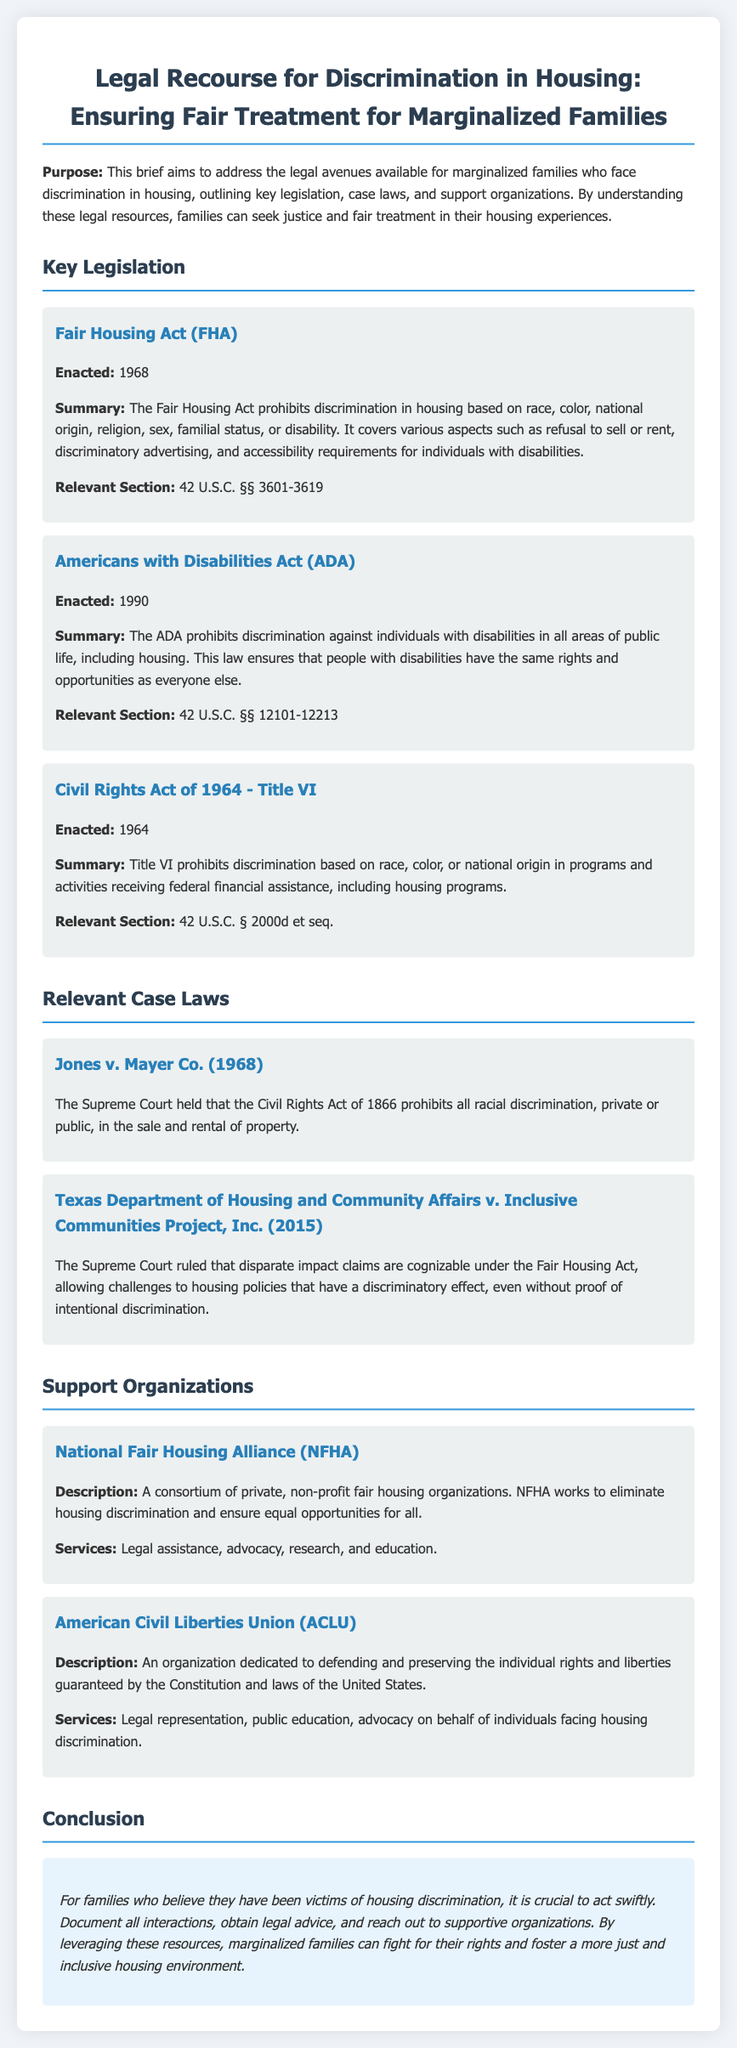what is the purpose of the brief? The purpose of the brief is to address the legal avenues available for marginalized families who face discrimination in housing, outlining key legislation, case laws, and support organizations.
Answer: To address legal avenues for marginalized families facing housing discrimination when was the Fair Housing Act enacted? The Fair Housing Act was enacted in 1968, as stated in the document.
Answer: 1968 what does the Americans with Disabilities Act prohibit? The Americans with Disabilities Act prohibits discrimination against individuals with disabilities in all areas of public life, including housing.
Answer: Discrimination against individuals with disabilities which organization works to eliminate housing discrimination? The National Fair Housing Alliance works to eliminate housing discrimination, as mentioned in the document.
Answer: National Fair Housing Alliance what was the Supreme Court ruling in Texas Department of Housing and Community Affairs v. Inclusive Communities Project, Inc.? The Supreme Court ruled that disparate impact claims are cognizable under the Fair Housing Act.
Answer: Disparate impact claims are cognizable under the Fair Housing Act how many key pieces of legislation are discussed in the document? The document discusses three key pieces of legislation related to housing discrimination.
Answer: Three what type of support does ACLU provide? The ACLU provides legal representation, public education, and advocacy on behalf of individuals facing housing discrimination.
Answer: Legal representation, public education, advocacy what should families do if they believe they have been victims of housing discrimination? Families should document all interactions, obtain legal advice, and reach out to supportive organizations.
Answer: Document interactions, obtain legal advice, reach out to organizations what is the relevant section for the Fair Housing Act? The relevant section for the Fair Housing Act is 42 U.S.C. §§ 3601-3619.
Answer: 42 U.S.C. §§ 3601-3619 